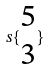Convert formula to latex. <formula><loc_0><loc_0><loc_500><loc_500>s \{ \begin{matrix} 5 \\ 3 \end{matrix} \}</formula> 